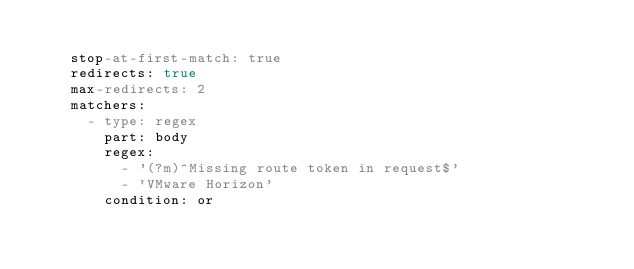<code> <loc_0><loc_0><loc_500><loc_500><_YAML_>
    stop-at-first-match: true
    redirects: true
    max-redirects: 2
    matchers:
      - type: regex
        part: body
        regex:
          - '(?m)^Missing route token in request$'
          - 'VMware Horizon'
        condition: or</code> 